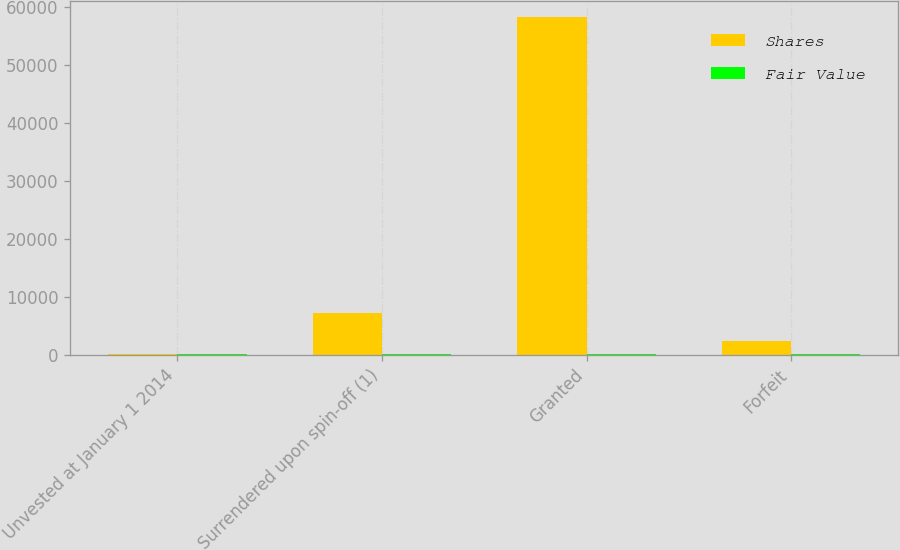<chart> <loc_0><loc_0><loc_500><loc_500><stacked_bar_chart><ecel><fcel>Unvested at January 1 2014<fcel>Surrendered upon spin-off (1)<fcel>Granted<fcel>Forfeit<nl><fcel>Shares<fcel>82.51<fcel>7177<fcel>58206<fcel>2381<nl><fcel>Fair Value<fcel>76.05<fcel>76.67<fcel>82.51<fcel>80.21<nl></chart> 